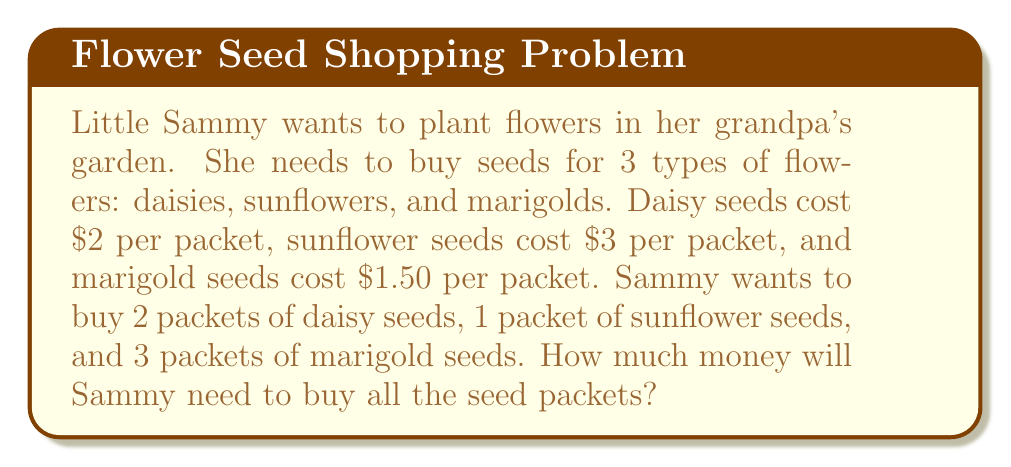Could you help me with this problem? Let's break this problem down step by step:

1. First, let's calculate the cost for each type of flower seed:

   Daisies: $2 per packet × 2 packets = $4
   $$2 \times 2 = 4$$

   Sunflowers: $3 per packet × 1 packet = $3
   $$3 \times 1 = 3$$

   Marigolds: $1.50 per packet × 3 packets = $4.50
   $$1.50 \times 3 = 4.50$$

2. Now, we need to add up the costs for all the seed packets:

   Total cost = Cost of daisies + Cost of sunflowers + Cost of marigolds
   $$\text{Total cost} = 4 + 3 + 4.50$$

3. Let's perform the addition:
   $$\text{Total cost} = 11.50$$

Therefore, Sammy will need $11.50 to buy all the seed packets.
Answer: $11.50 